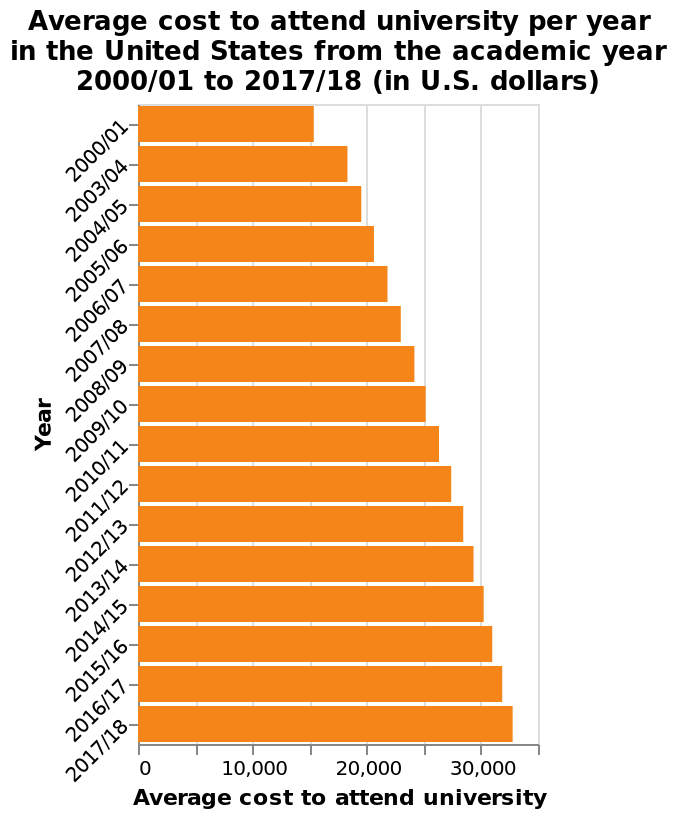<image>
What is the trend in the average cost to attend university per year in the United States?  The average cost to attend university per year in the United States has increased every year. 